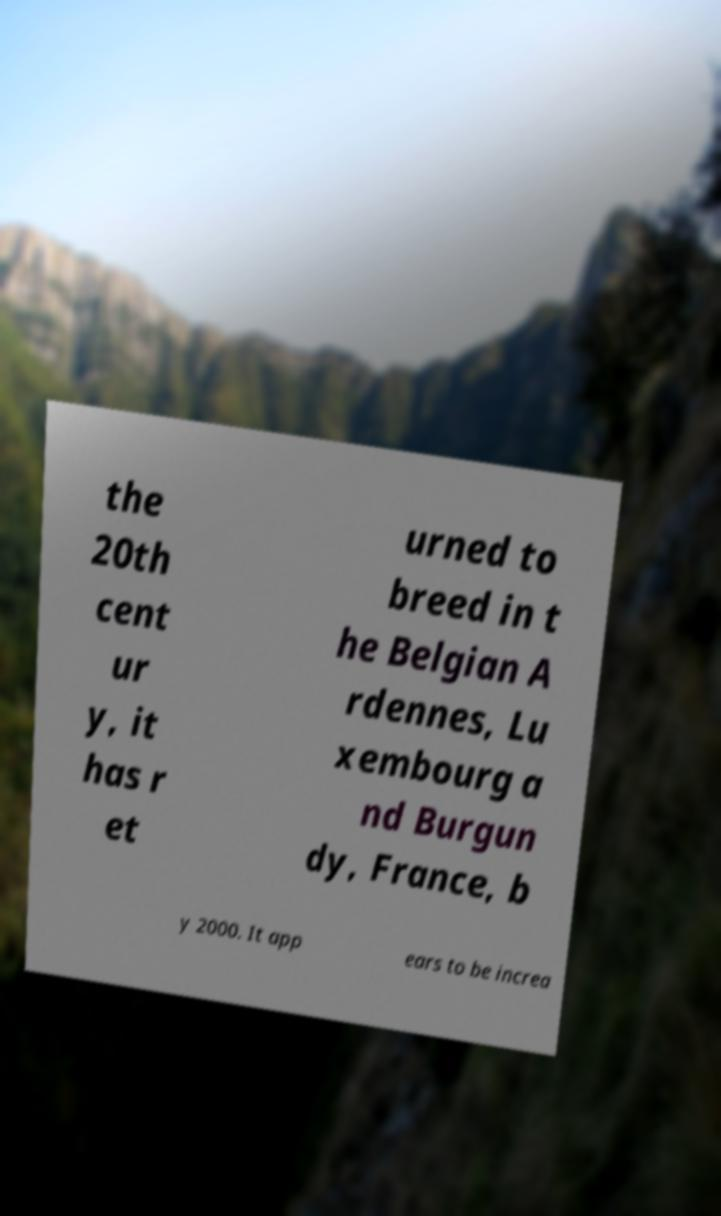Can you read and provide the text displayed in the image?This photo seems to have some interesting text. Can you extract and type it out for me? the 20th cent ur y, it has r et urned to breed in t he Belgian A rdennes, Lu xembourg a nd Burgun dy, France, b y 2000. It app ears to be increa 